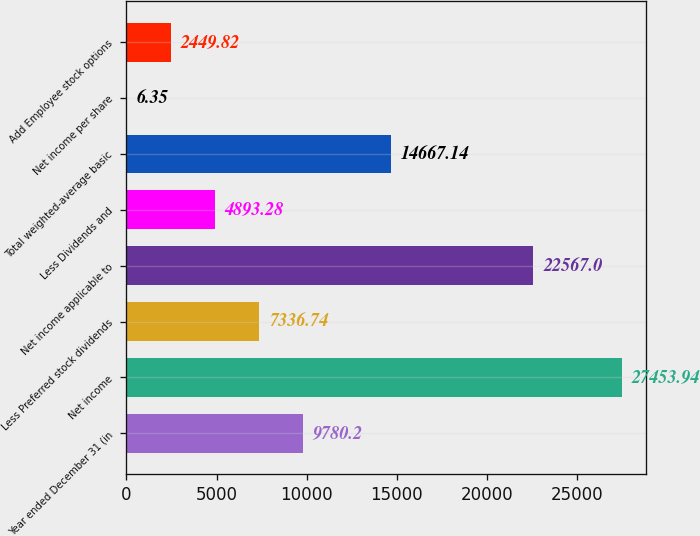Convert chart. <chart><loc_0><loc_0><loc_500><loc_500><bar_chart><fcel>Year ended December 31 (in<fcel>Net income<fcel>Less Preferred stock dividends<fcel>Net income applicable to<fcel>Less Dividends and<fcel>Total weighted-average basic<fcel>Net income per share<fcel>Add Employee stock options<nl><fcel>9780.2<fcel>27453.9<fcel>7336.74<fcel>22567<fcel>4893.28<fcel>14667.1<fcel>6.35<fcel>2449.82<nl></chart> 